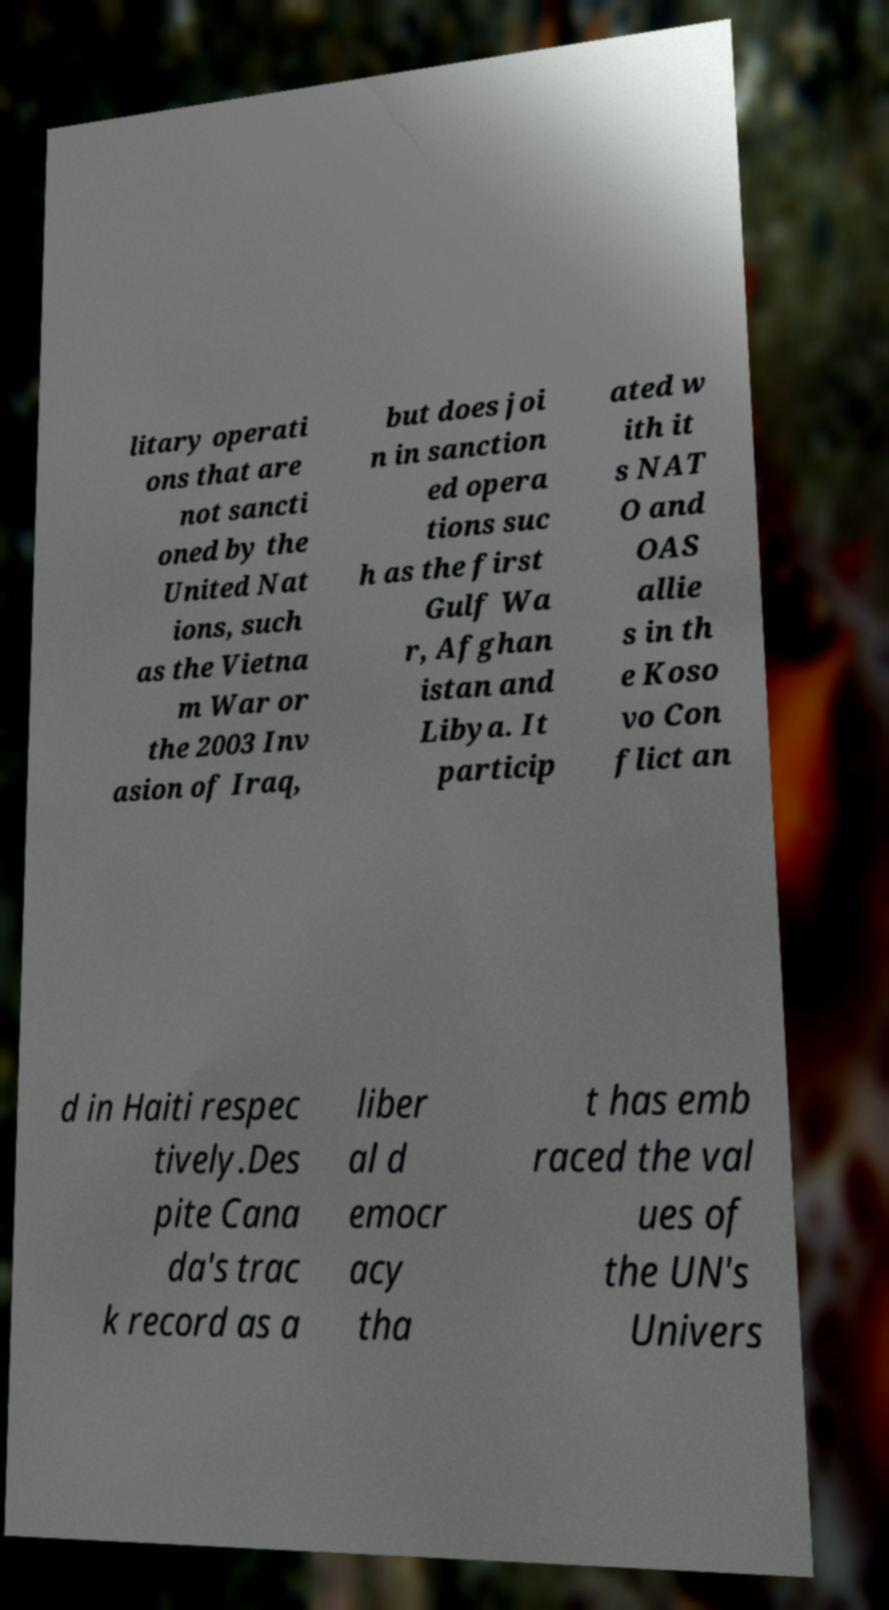Please identify and transcribe the text found in this image. litary operati ons that are not sancti oned by the United Nat ions, such as the Vietna m War or the 2003 Inv asion of Iraq, but does joi n in sanction ed opera tions suc h as the first Gulf Wa r, Afghan istan and Libya. It particip ated w ith it s NAT O and OAS allie s in th e Koso vo Con flict an d in Haiti respec tively.Des pite Cana da's trac k record as a liber al d emocr acy tha t has emb raced the val ues of the UN's Univers 